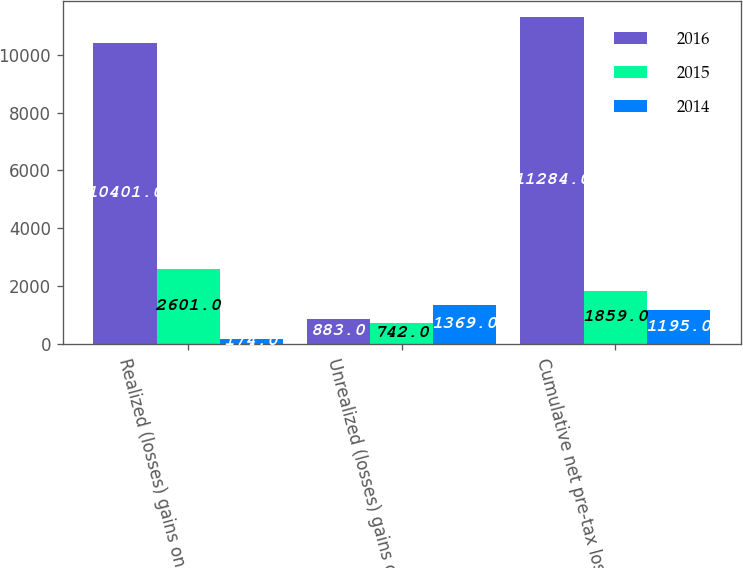Convert chart. <chart><loc_0><loc_0><loc_500><loc_500><stacked_bar_chart><ecel><fcel>Realized (losses) gains on<fcel>Unrealized (losses) gains on<fcel>Cumulative net pre-tax losses<nl><fcel>2016<fcel>10401<fcel>883<fcel>11284<nl><fcel>2015<fcel>2601<fcel>742<fcel>1859<nl><fcel>2014<fcel>174<fcel>1369<fcel>1195<nl></chart> 